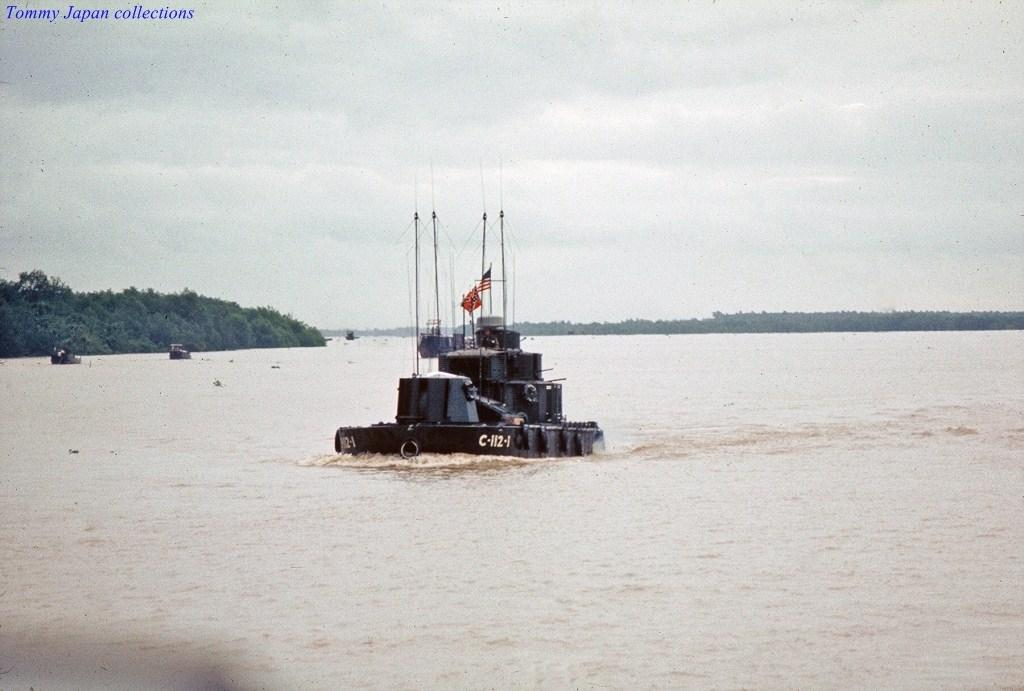<image>
Provide a brief description of the given image. A picture in the Tommy Japan collections depicting the US submarine C-112-4. 